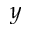Convert formula to latex. <formula><loc_0><loc_0><loc_500><loc_500>y</formula> 